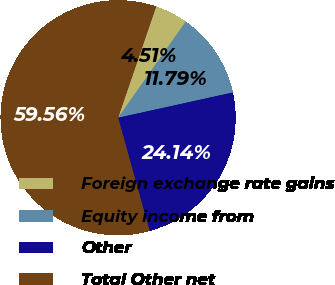<chart> <loc_0><loc_0><loc_500><loc_500><pie_chart><fcel>Foreign exchange rate gains<fcel>Equity income from<fcel>Other<fcel>Total Other net<nl><fcel>4.51%<fcel>11.79%<fcel>24.14%<fcel>59.56%<nl></chart> 